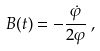Convert formula to latex. <formula><loc_0><loc_0><loc_500><loc_500>B ( t ) = - \frac { \dot { \varphi } } { 2 \varphi } \, ,</formula> 